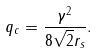Convert formula to latex. <formula><loc_0><loc_0><loc_500><loc_500>q _ { c } = \frac { \gamma ^ { 2 } } { 8 \sqrt { 2 } r _ { s } } .</formula> 